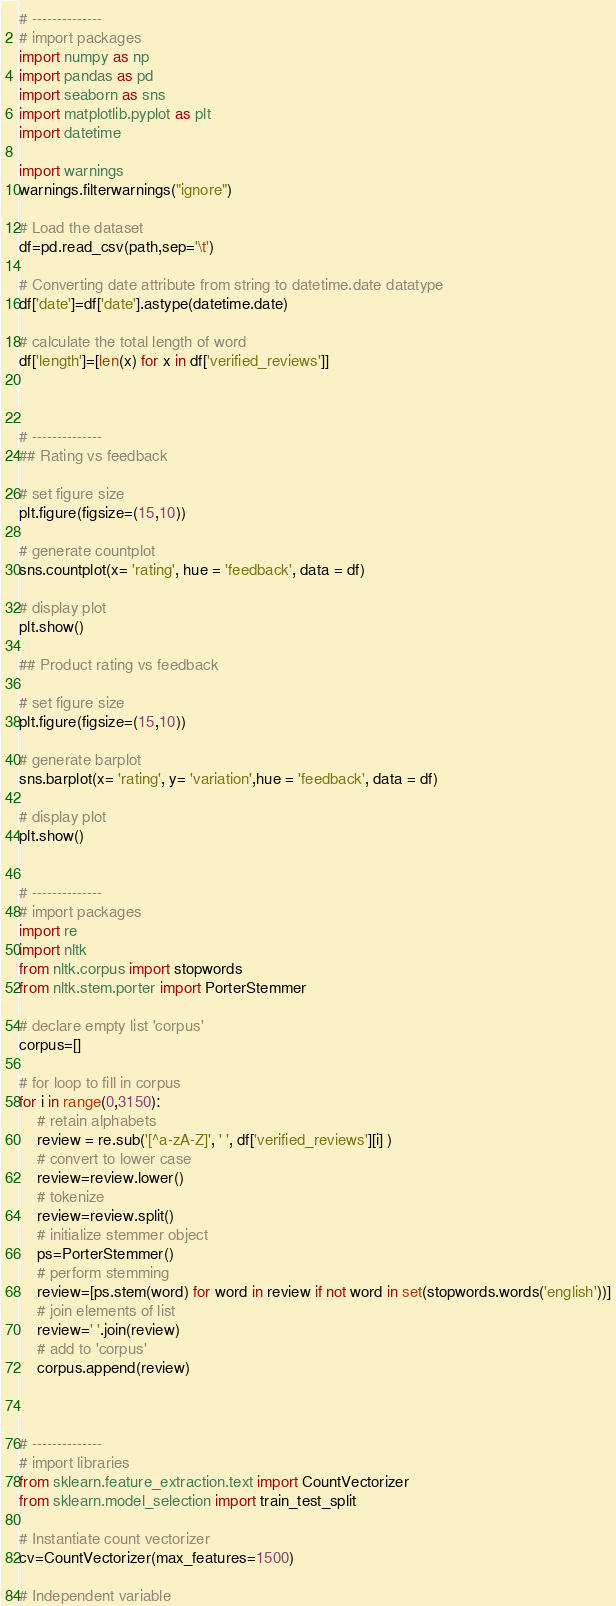Convert code to text. <code><loc_0><loc_0><loc_500><loc_500><_Python_># --------------
# import packages
import numpy as np
import pandas as pd
import seaborn as sns
import matplotlib.pyplot as plt
import datetime

import warnings
warnings.filterwarnings("ignore")

# Load the dataset
df=pd.read_csv(path,sep='\t')

# Converting date attribute from string to datetime.date datatype 
df['date']=df['date'].astype(datetime.date)

# calculate the total length of word
df['length']=[len(x) for x in df['verified_reviews']]



# --------------
## Rating vs feedback

# set figure size
plt.figure(figsize=(15,10))

# generate countplot
sns.countplot(x= 'rating', hue = 'feedback', data = df)

# display plot
plt.show()

## Product rating vs feedback

# set figure size
plt.figure(figsize=(15,10))

# generate barplot
sns.barplot(x= 'rating', y= 'variation',hue = 'feedback', data = df)

# display plot
plt.show()


# --------------
# import packages
import re
import nltk
from nltk.corpus import stopwords
from nltk.stem.porter import PorterStemmer

# declare empty list 'corpus'
corpus=[]

# for loop to fill in corpus
for i in range(0,3150):
    # retain alphabets
    review = re.sub('[^a-zA-Z]', ' ', df['verified_reviews'][i] )
    # convert to lower case
    review=review.lower()
    # tokenize
    review=review.split()
    # initialize stemmer object
    ps=PorterStemmer()
    # perform stemming
    review=[ps.stem(word) for word in review if not word in set(stopwords.words('english'))]
    # join elements of list
    review=' '.join(review)
    # add to 'corpus'
    corpus.append(review)
    


# --------------
# import libraries
from sklearn.feature_extraction.text import CountVectorizer
from sklearn.model_selection import train_test_split

# Instantiate count vectorizer
cv=CountVectorizer(max_features=1500)

# Independent variable</code> 